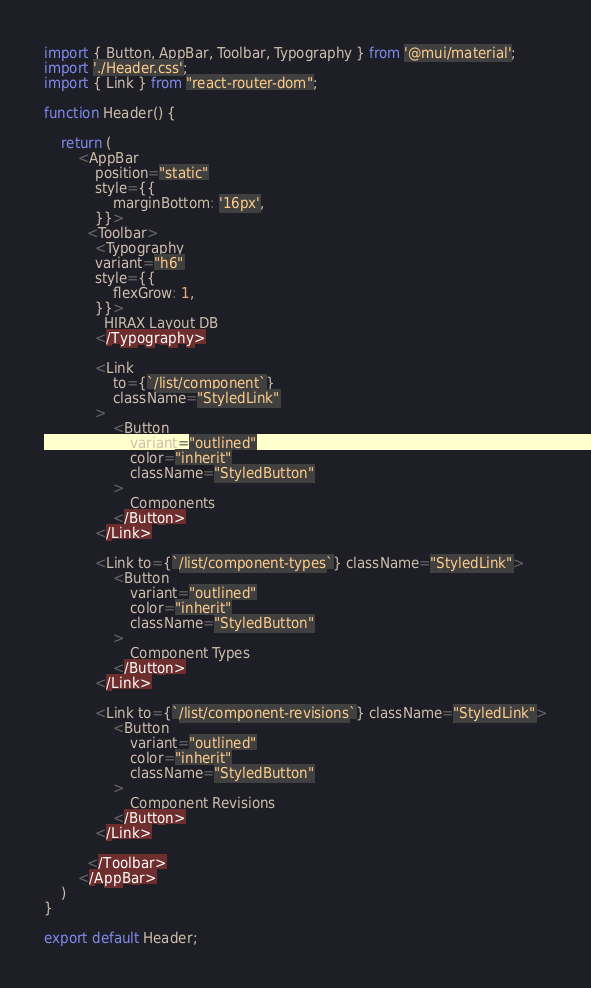<code> <loc_0><loc_0><loc_500><loc_500><_JavaScript_>import { Button, AppBar, Toolbar, Typography } from '@mui/material';
import './Header.css';
import { Link } from "react-router-dom";

function Header() {

    return (
        <AppBar 
            position="static"
            style={{
                marginBottom: '16px',
            }}>
          <Toolbar>
            <Typography 
            variant="h6"
            style={{
                flexGrow: 1,
            }}>
              HIRAX Layout DB
            </Typography>

            <Link 
                to={`/list/component`}
                className="StyledLink"
            >
                <Button 
                    variant="outlined" 
                    color="inherit" 
                    className="StyledButton"
                >
                    Components
                </Button>
            </Link>
            
            <Link to={`/list/component-types`} className="StyledLink">
                <Button 
                    variant="outlined" 
                    color="inherit"
                    className="StyledButton"
                >
                    Component Types
                </Button>
            </Link>

            <Link to={`/list/component-revisions`} className="StyledLink">
                <Button 
                    variant="outlined" 
                    color="inherit"
                    className="StyledButton"
                >
                    Component Revisions
                </Button>
            </Link>

          </Toolbar>
        </AppBar>
    )
}

export default Header;
</code> 